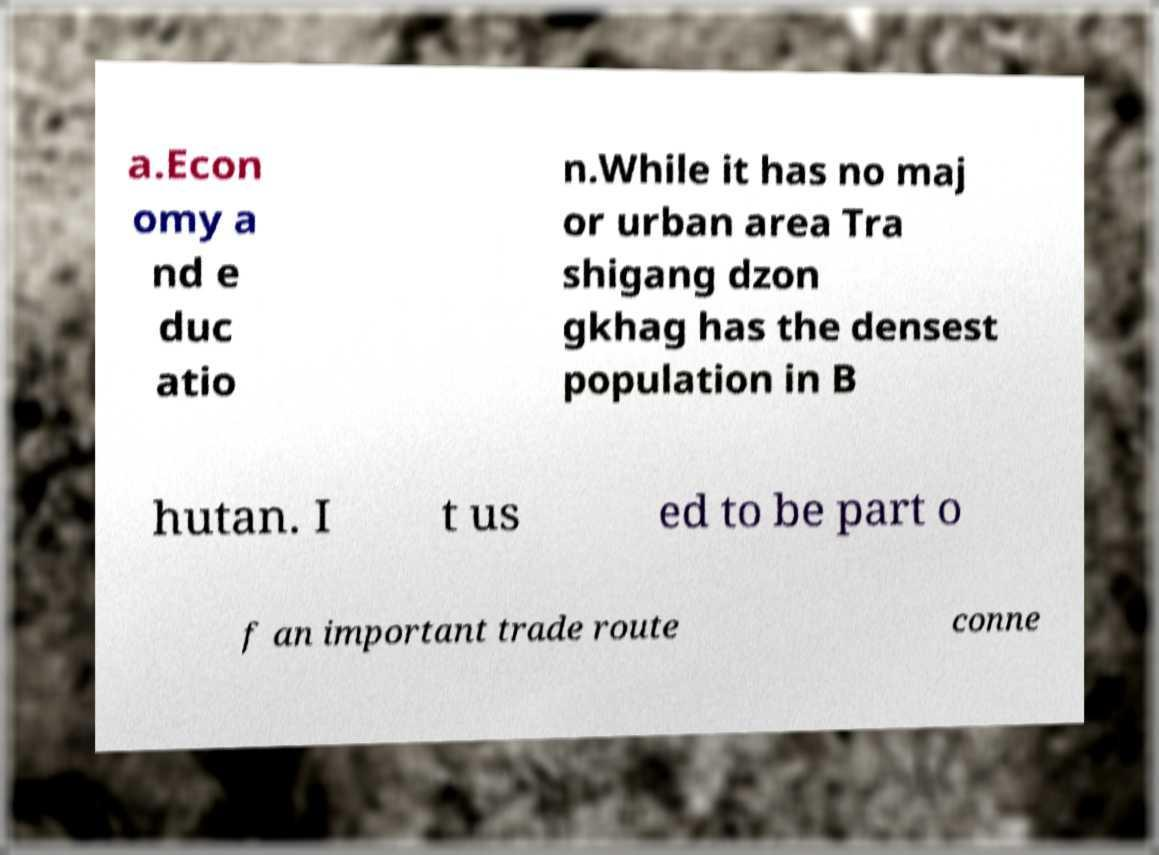Please identify and transcribe the text found in this image. a.Econ omy a nd e duc atio n.While it has no maj or urban area Tra shigang dzon gkhag has the densest population in B hutan. I t us ed to be part o f an important trade route conne 